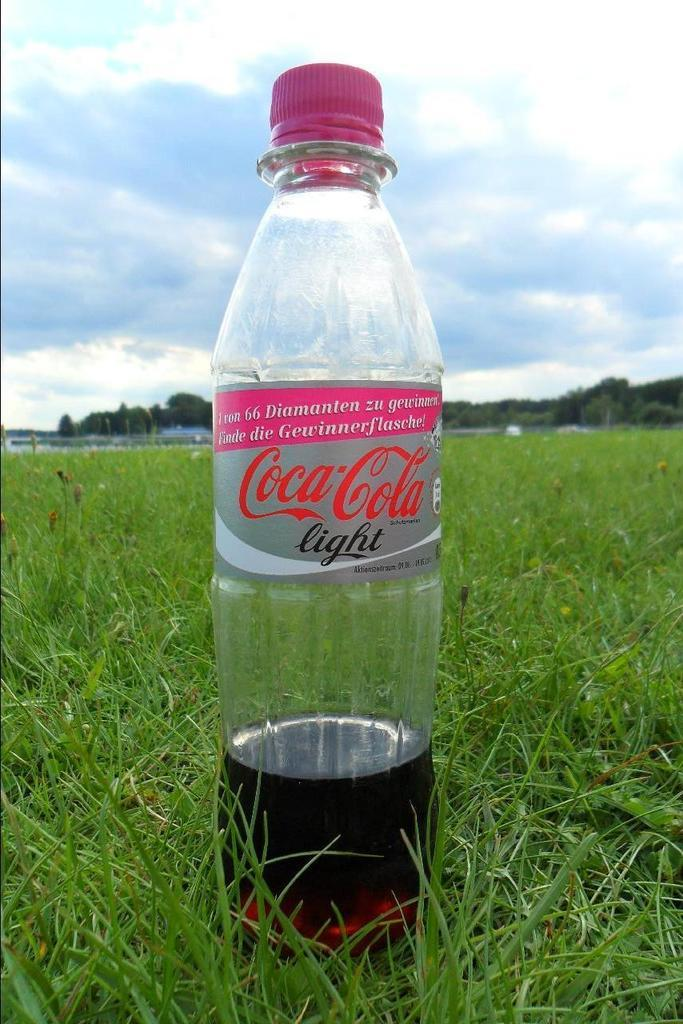What object is present in the image that contains a drink? There is a bottle in the image that has a drink inside. What is the color of the bottle's cap? The bottle has a pink-colored cap. Where is the bottle placed? The bottle is placed on grassy land. What can be seen in the background of the image? There are trees and the sky visible in the background of the image. What is the condition of the sky in the image? The sky has clouds in it. How does the toothbrush help the person hear better in the image? There is no toothbrush or indication of hearing in the image; it features a bottle with a drink and a pink-colored cap. What type of star can be seen in the image? There is no star present in the image; it features a bottle with a drink, a pink-colored cap, grassy land, trees, and a cloudy sky. 